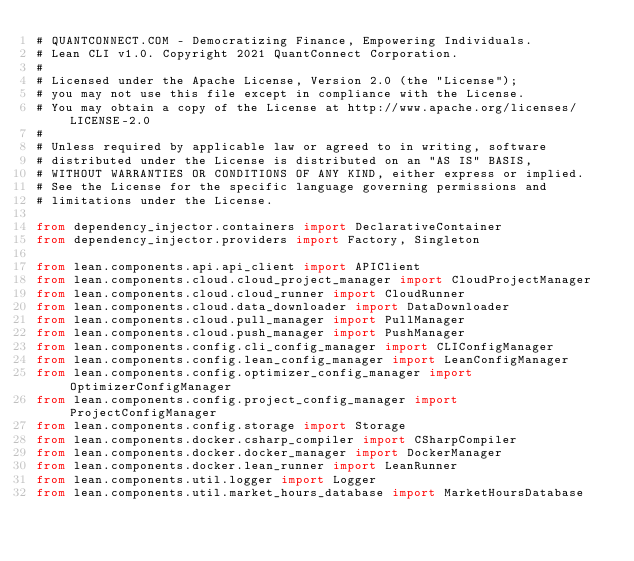<code> <loc_0><loc_0><loc_500><loc_500><_Python_># QUANTCONNECT.COM - Democratizing Finance, Empowering Individuals.
# Lean CLI v1.0. Copyright 2021 QuantConnect Corporation.
#
# Licensed under the Apache License, Version 2.0 (the "License");
# you may not use this file except in compliance with the License.
# You may obtain a copy of the License at http://www.apache.org/licenses/LICENSE-2.0
#
# Unless required by applicable law or agreed to in writing, software
# distributed under the License is distributed on an "AS IS" BASIS,
# WITHOUT WARRANTIES OR CONDITIONS OF ANY KIND, either express or implied.
# See the License for the specific language governing permissions and
# limitations under the License.

from dependency_injector.containers import DeclarativeContainer
from dependency_injector.providers import Factory, Singleton

from lean.components.api.api_client import APIClient
from lean.components.cloud.cloud_project_manager import CloudProjectManager
from lean.components.cloud.cloud_runner import CloudRunner
from lean.components.cloud.data_downloader import DataDownloader
from lean.components.cloud.pull_manager import PullManager
from lean.components.cloud.push_manager import PushManager
from lean.components.config.cli_config_manager import CLIConfigManager
from lean.components.config.lean_config_manager import LeanConfigManager
from lean.components.config.optimizer_config_manager import OptimizerConfigManager
from lean.components.config.project_config_manager import ProjectConfigManager
from lean.components.config.storage import Storage
from lean.components.docker.csharp_compiler import CSharpCompiler
from lean.components.docker.docker_manager import DockerManager
from lean.components.docker.lean_runner import LeanRunner
from lean.components.util.logger import Logger
from lean.components.util.market_hours_database import MarketHoursDatabase</code> 